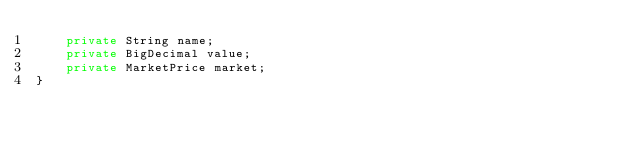Convert code to text. <code><loc_0><loc_0><loc_500><loc_500><_Java_>    private String name;
    private BigDecimal value;
    private MarketPrice market;
}
</code> 